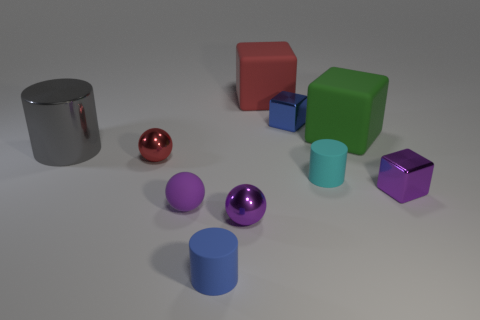Subtract all metallic cylinders. How many cylinders are left? 2 Subtract all cyan cubes. How many purple balls are left? 2 Subtract 1 balls. How many balls are left? 2 Subtract all green blocks. How many blocks are left? 3 Subtract all purple cylinders. Subtract all blue blocks. How many cylinders are left? 3 Subtract all small cyan things. Subtract all blue rubber spheres. How many objects are left? 9 Add 1 small cyan matte cylinders. How many small cyan matte cylinders are left? 2 Add 1 tiny cyan things. How many tiny cyan things exist? 2 Subtract 1 cyan cylinders. How many objects are left? 9 Subtract all blocks. How many objects are left? 6 